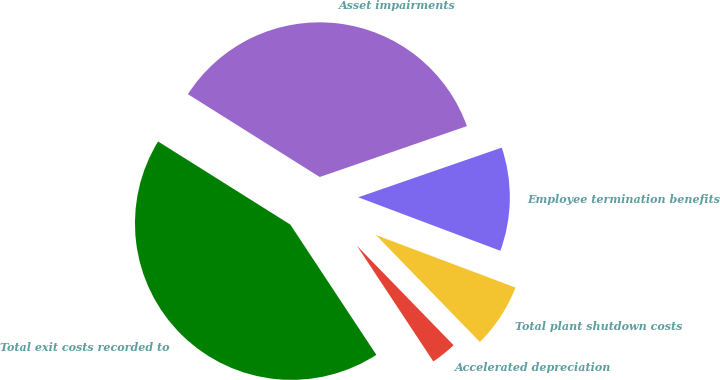Convert chart to OTSL. <chart><loc_0><loc_0><loc_500><loc_500><pie_chart><fcel>Employee termination benefits<fcel>Asset impairments<fcel>Total exit costs recorded to<fcel>Accelerated depreciation<fcel>Total plant shutdown costs<nl><fcel>11.03%<fcel>35.77%<fcel>43.22%<fcel>2.98%<fcel>7.0%<nl></chart> 